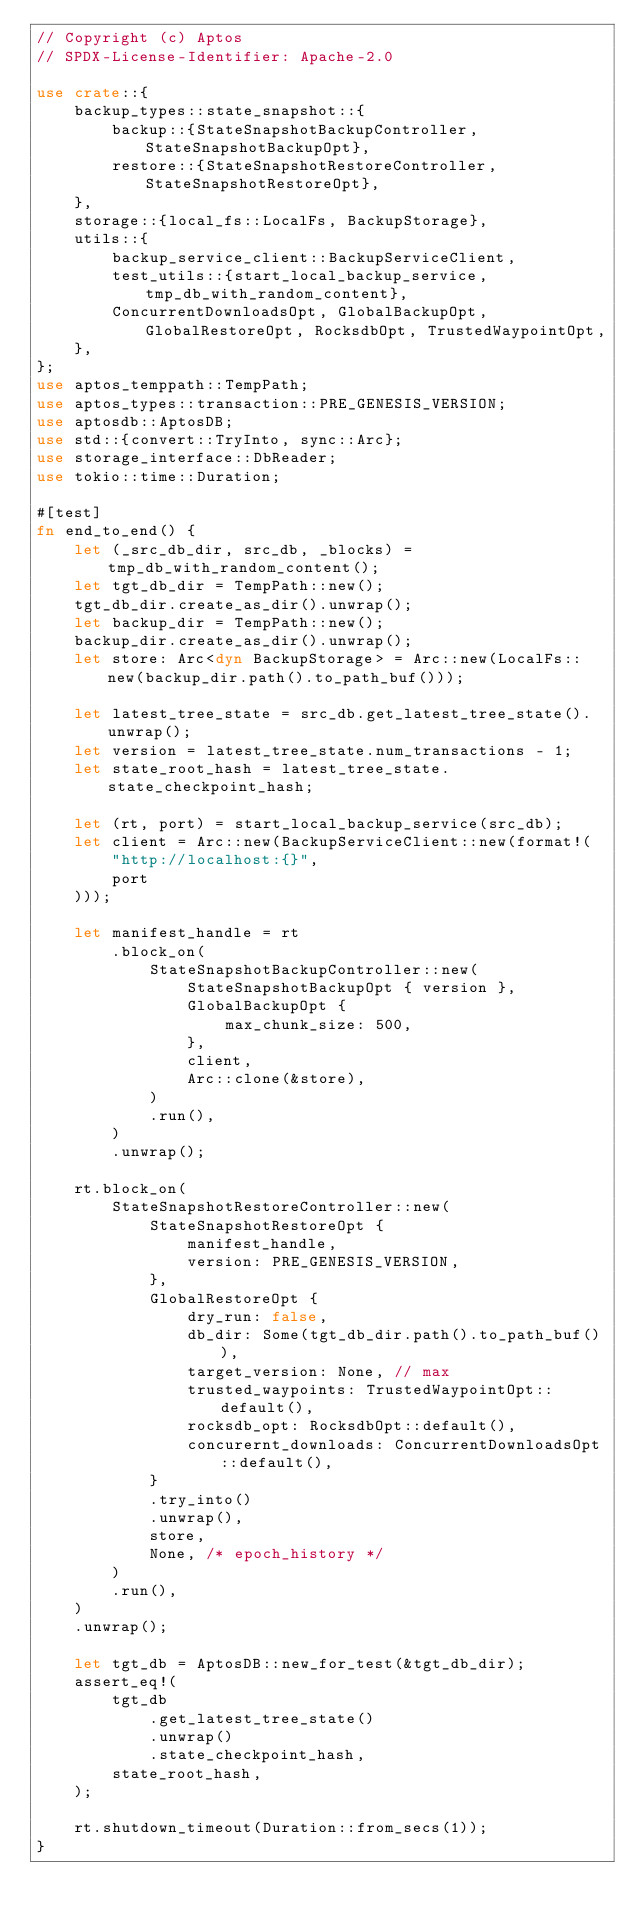<code> <loc_0><loc_0><loc_500><loc_500><_Rust_>// Copyright (c) Aptos
// SPDX-License-Identifier: Apache-2.0

use crate::{
    backup_types::state_snapshot::{
        backup::{StateSnapshotBackupController, StateSnapshotBackupOpt},
        restore::{StateSnapshotRestoreController, StateSnapshotRestoreOpt},
    },
    storage::{local_fs::LocalFs, BackupStorage},
    utils::{
        backup_service_client::BackupServiceClient,
        test_utils::{start_local_backup_service, tmp_db_with_random_content},
        ConcurrentDownloadsOpt, GlobalBackupOpt, GlobalRestoreOpt, RocksdbOpt, TrustedWaypointOpt,
    },
};
use aptos_temppath::TempPath;
use aptos_types::transaction::PRE_GENESIS_VERSION;
use aptosdb::AptosDB;
use std::{convert::TryInto, sync::Arc};
use storage_interface::DbReader;
use tokio::time::Duration;

#[test]
fn end_to_end() {
    let (_src_db_dir, src_db, _blocks) = tmp_db_with_random_content();
    let tgt_db_dir = TempPath::new();
    tgt_db_dir.create_as_dir().unwrap();
    let backup_dir = TempPath::new();
    backup_dir.create_as_dir().unwrap();
    let store: Arc<dyn BackupStorage> = Arc::new(LocalFs::new(backup_dir.path().to_path_buf()));

    let latest_tree_state = src_db.get_latest_tree_state().unwrap();
    let version = latest_tree_state.num_transactions - 1;
    let state_root_hash = latest_tree_state.state_checkpoint_hash;

    let (rt, port) = start_local_backup_service(src_db);
    let client = Arc::new(BackupServiceClient::new(format!(
        "http://localhost:{}",
        port
    )));

    let manifest_handle = rt
        .block_on(
            StateSnapshotBackupController::new(
                StateSnapshotBackupOpt { version },
                GlobalBackupOpt {
                    max_chunk_size: 500,
                },
                client,
                Arc::clone(&store),
            )
            .run(),
        )
        .unwrap();

    rt.block_on(
        StateSnapshotRestoreController::new(
            StateSnapshotRestoreOpt {
                manifest_handle,
                version: PRE_GENESIS_VERSION,
            },
            GlobalRestoreOpt {
                dry_run: false,
                db_dir: Some(tgt_db_dir.path().to_path_buf()),
                target_version: None, // max
                trusted_waypoints: TrustedWaypointOpt::default(),
                rocksdb_opt: RocksdbOpt::default(),
                concurernt_downloads: ConcurrentDownloadsOpt::default(),
            }
            .try_into()
            .unwrap(),
            store,
            None, /* epoch_history */
        )
        .run(),
    )
    .unwrap();

    let tgt_db = AptosDB::new_for_test(&tgt_db_dir);
    assert_eq!(
        tgt_db
            .get_latest_tree_state()
            .unwrap()
            .state_checkpoint_hash,
        state_root_hash,
    );

    rt.shutdown_timeout(Duration::from_secs(1));
}
</code> 